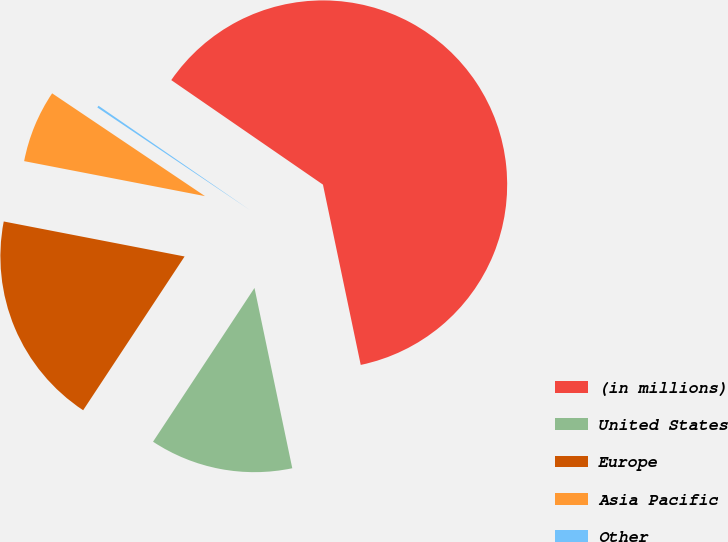Convert chart. <chart><loc_0><loc_0><loc_500><loc_500><pie_chart><fcel>(in millions)<fcel>United States<fcel>Europe<fcel>Asia Pacific<fcel>Other<nl><fcel>62.11%<fcel>12.57%<fcel>18.76%<fcel>6.38%<fcel>0.18%<nl></chart> 